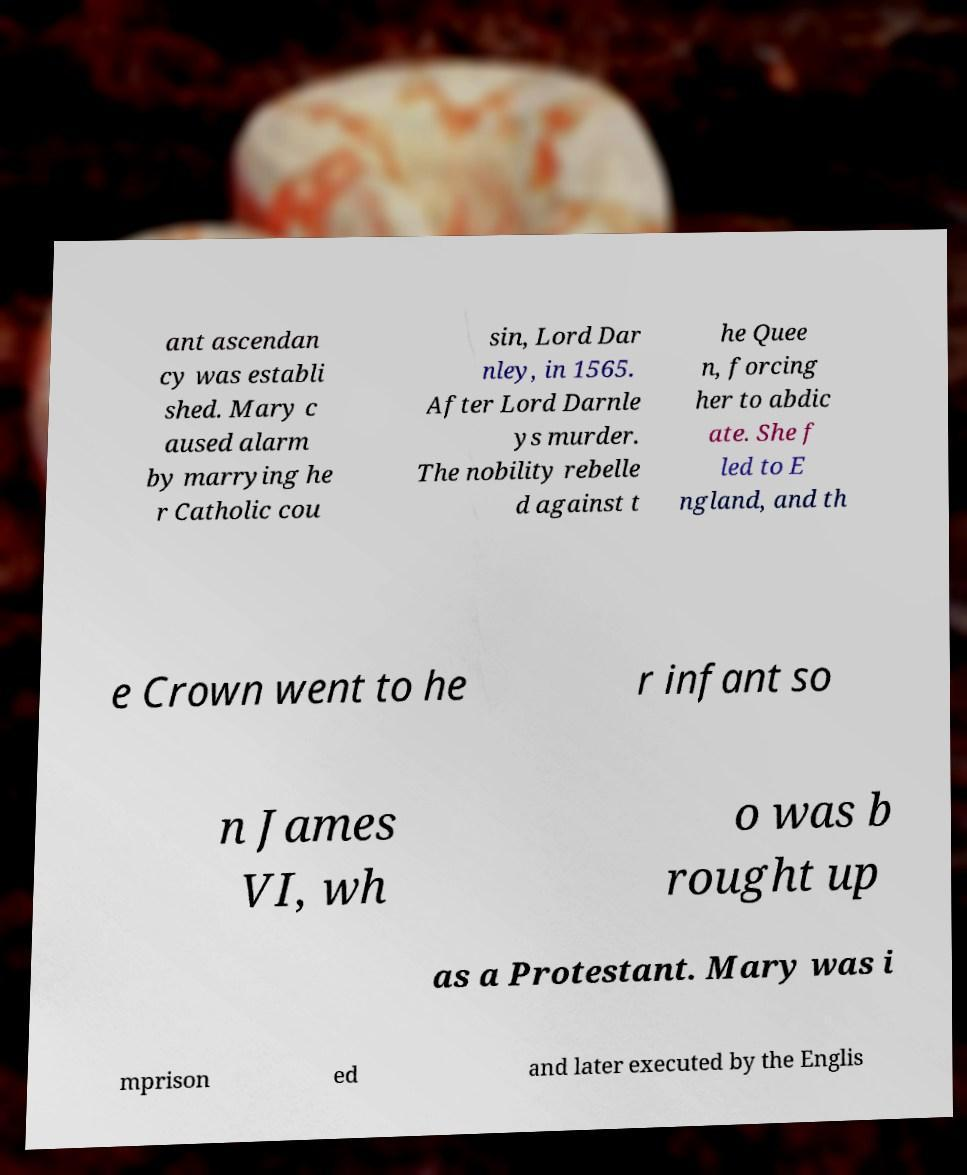Can you accurately transcribe the text from the provided image for me? ant ascendan cy was establi shed. Mary c aused alarm by marrying he r Catholic cou sin, Lord Dar nley, in 1565. After Lord Darnle ys murder. The nobility rebelle d against t he Quee n, forcing her to abdic ate. She f led to E ngland, and th e Crown went to he r infant so n James VI, wh o was b rought up as a Protestant. Mary was i mprison ed and later executed by the Englis 